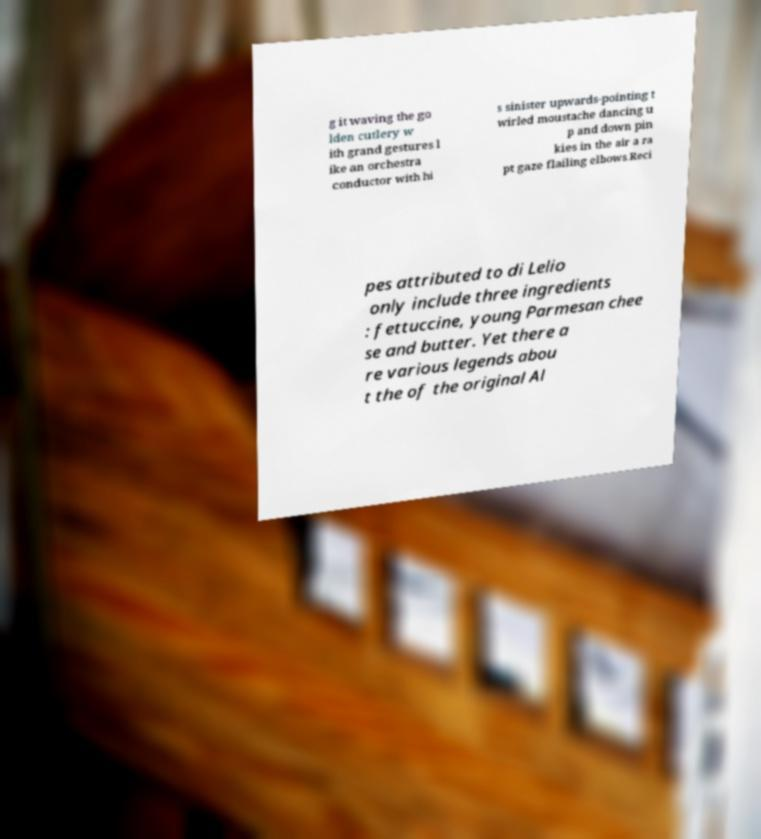For documentation purposes, I need the text within this image transcribed. Could you provide that? g it waving the go lden cutlery w ith grand gestures l ike an orchestra conductor with hi s sinister upwards-pointing t wirled moustache dancing u p and down pin kies in the air a ra pt gaze flailing elbows.Reci pes attributed to di Lelio only include three ingredients : fettuccine, young Parmesan chee se and butter. Yet there a re various legends abou t the of the original Al 